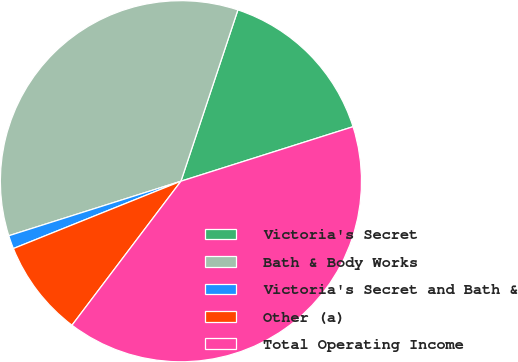Convert chart. <chart><loc_0><loc_0><loc_500><loc_500><pie_chart><fcel>Victoria's Secret<fcel>Bath & Body Works<fcel>Victoria's Secret and Bath &<fcel>Other (a)<fcel>Total Operating Income<nl><fcel>15.01%<fcel>34.99%<fcel>1.2%<fcel>8.61%<fcel>40.19%<nl></chart> 